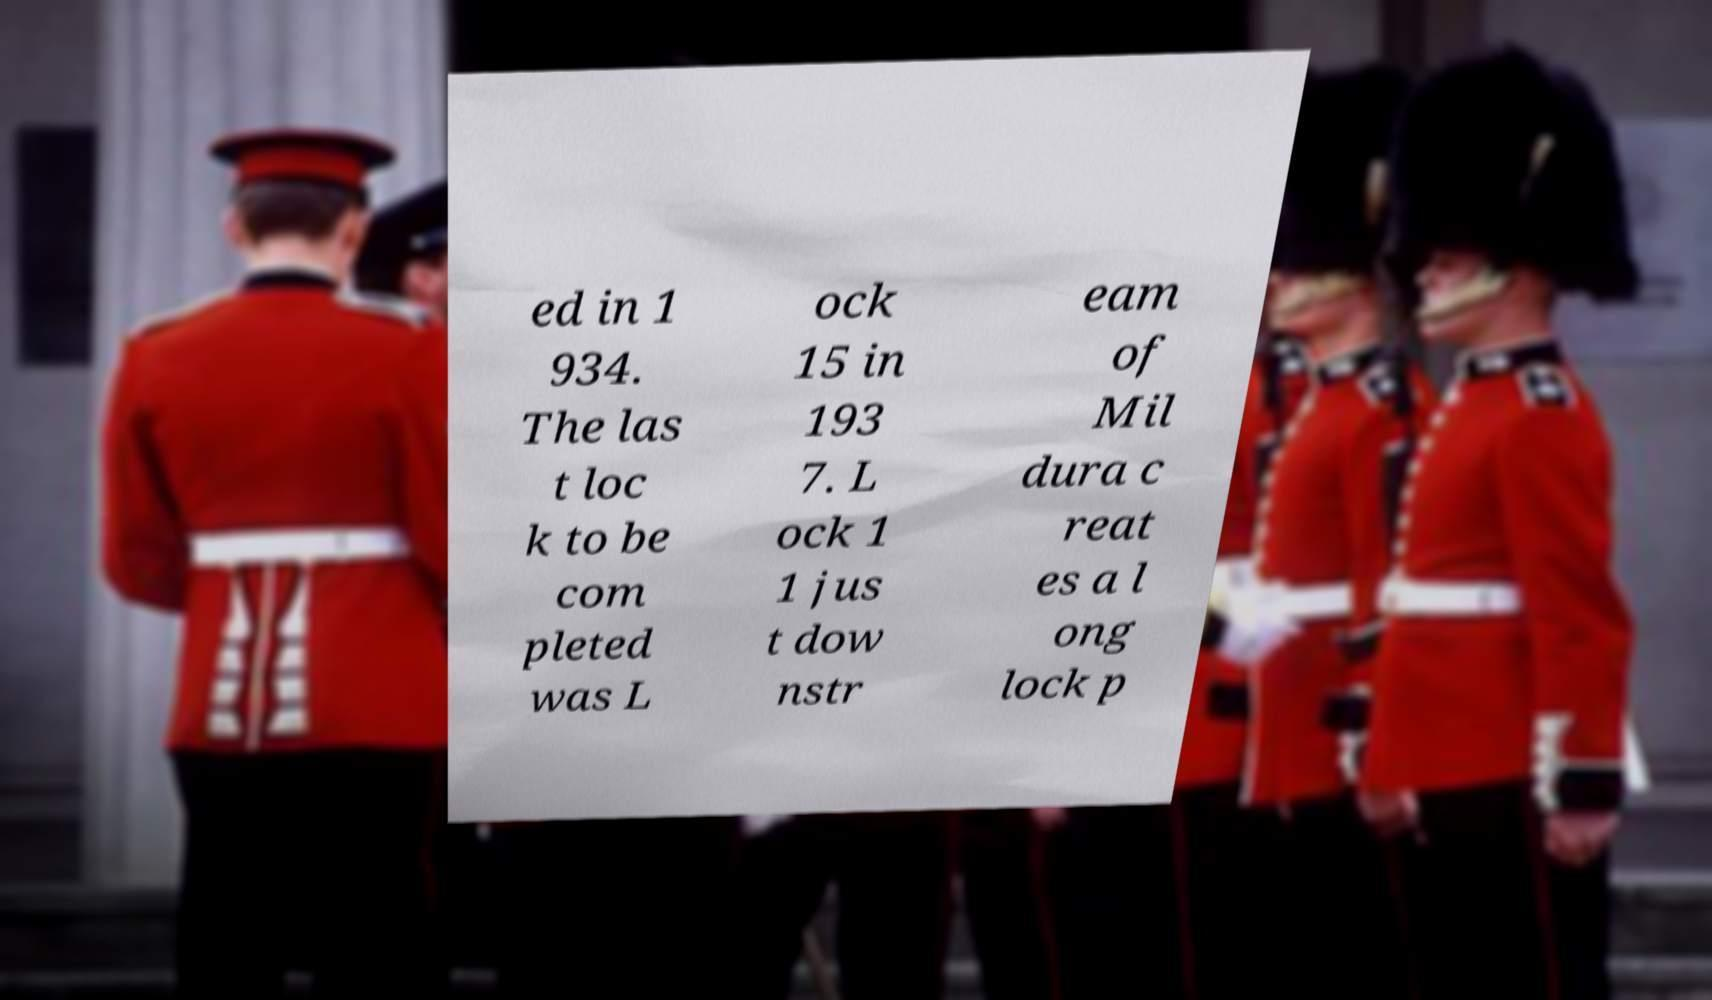Please read and relay the text visible in this image. What does it say? ed in 1 934. The las t loc k to be com pleted was L ock 15 in 193 7. L ock 1 1 jus t dow nstr eam of Mil dura c reat es a l ong lock p 